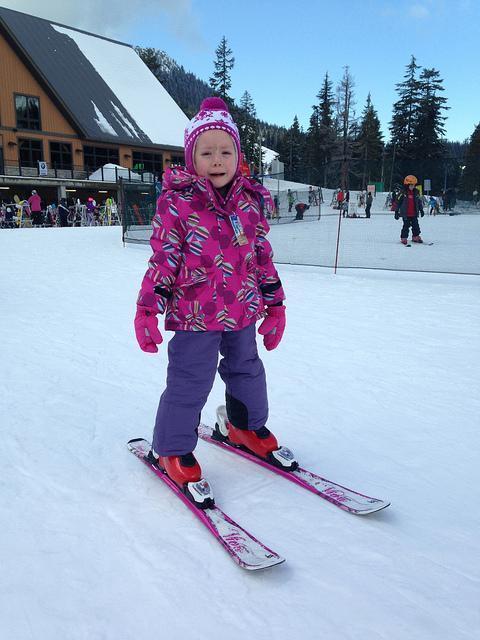How many people are there?
Give a very brief answer. 1. 